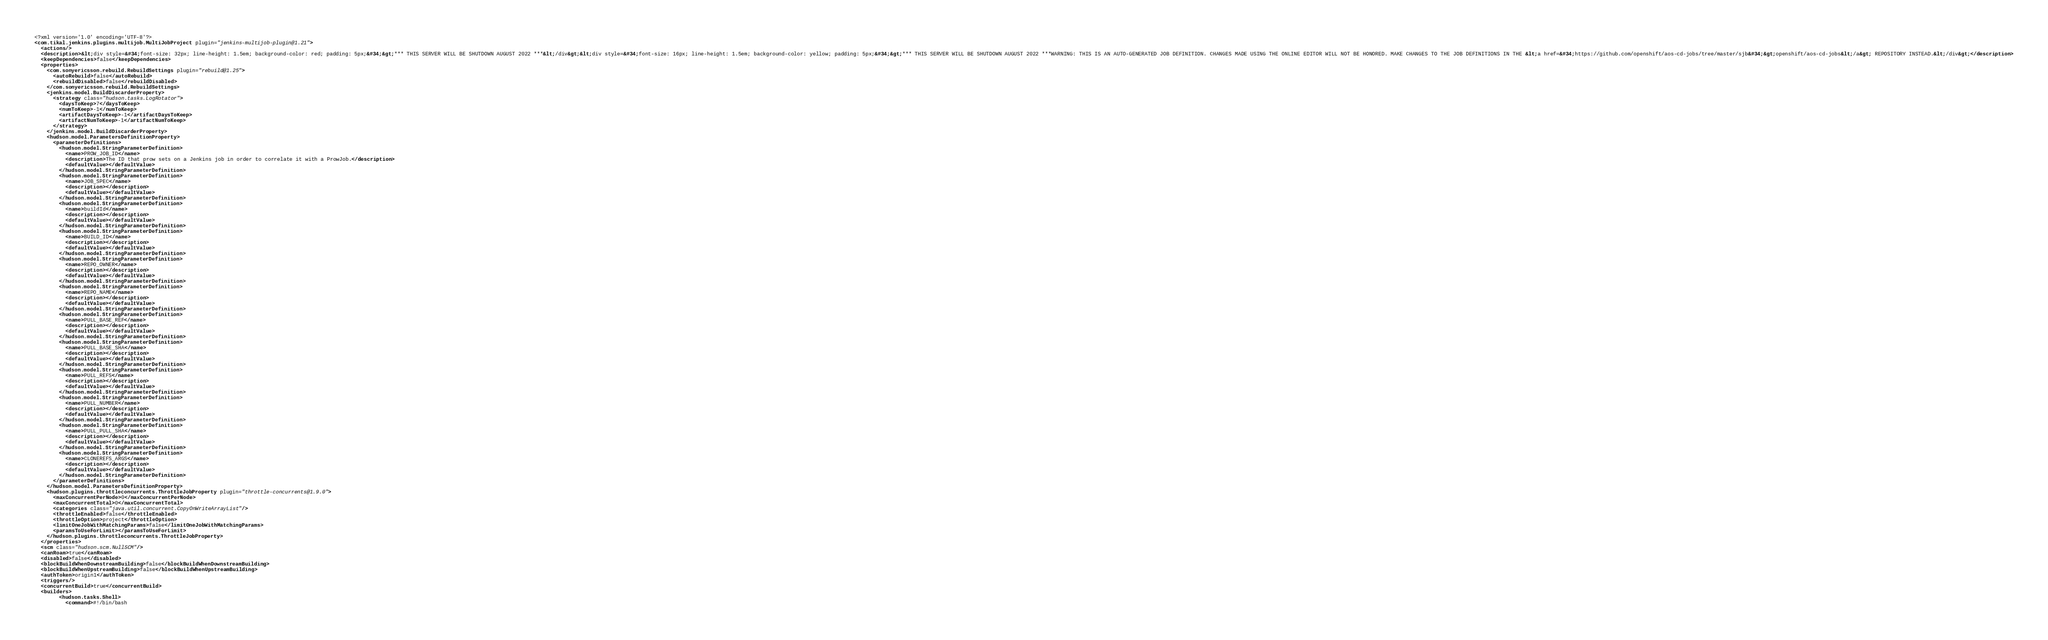<code> <loc_0><loc_0><loc_500><loc_500><_XML_><?xml version='1.0' encoding='UTF-8'?>
<com.tikal.jenkins.plugins.multijob.MultiJobProject plugin="jenkins-multijob-plugin@1.21">
  <actions/>
  <description>&lt;div style=&#34;font-size: 32px; line-height: 1.5em; background-color: red; padding: 5px;&#34;&gt;*** THIS SERVER WILL BE SHUTDOWN AUGUST 2022 ***&lt;/div&gt;&lt;div style=&#34;font-size: 16px; line-height: 1.5em; background-color: yellow; padding: 5px;&#34;&gt;*** THIS SERVER WILL BE SHUTDOWN AUGUST 2022 ***WARNING: THIS IS AN AUTO-GENERATED JOB DEFINITION. CHANGES MADE USING THE ONLINE EDITOR WILL NOT BE HONORED. MAKE CHANGES TO THE JOB DEFINITIONS IN THE &lt;a href=&#34;https://github.com/openshift/aos-cd-jobs/tree/master/sjb&#34;&gt;openshift/aos-cd-jobs&lt;/a&gt; REPOSITORY INSTEAD.&lt;/div&gt;</description>
  <keepDependencies>false</keepDependencies>
  <properties>
    <com.sonyericsson.rebuild.RebuildSettings plugin="rebuild@1.25">
      <autoRebuild>false</autoRebuild>
      <rebuildDisabled>false</rebuildDisabled>
    </com.sonyericsson.rebuild.RebuildSettings>
    <jenkins.model.BuildDiscarderProperty>
      <strategy class="hudson.tasks.LogRotator">
        <daysToKeep>7</daysToKeep>
        <numToKeep>-1</numToKeep>
        <artifactDaysToKeep>-1</artifactDaysToKeep>
        <artifactNumToKeep>-1</artifactNumToKeep>
      </strategy>
    </jenkins.model.BuildDiscarderProperty>
    <hudson.model.ParametersDefinitionProperty>
      <parameterDefinitions>
        <hudson.model.StringParameterDefinition>
          <name>PROW_JOB_ID</name>
          <description>The ID that prow sets on a Jenkins job in order to correlate it with a ProwJob.</description>
          <defaultValue></defaultValue>
        </hudson.model.StringParameterDefinition>
        <hudson.model.StringParameterDefinition>
          <name>JOB_SPEC</name>
          <description></description>
          <defaultValue></defaultValue>
        </hudson.model.StringParameterDefinition>
        <hudson.model.StringParameterDefinition>
          <name>buildId</name>
          <description></description>
          <defaultValue></defaultValue>
        </hudson.model.StringParameterDefinition>
        <hudson.model.StringParameterDefinition>
          <name>BUILD_ID</name>
          <description></description>
          <defaultValue></defaultValue>
        </hudson.model.StringParameterDefinition>
        <hudson.model.StringParameterDefinition>
          <name>REPO_OWNER</name>
          <description></description>
          <defaultValue></defaultValue>
        </hudson.model.StringParameterDefinition>
        <hudson.model.StringParameterDefinition>
          <name>REPO_NAME</name>
          <description></description>
          <defaultValue></defaultValue>
        </hudson.model.StringParameterDefinition>
        <hudson.model.StringParameterDefinition>
          <name>PULL_BASE_REF</name>
          <description></description>
          <defaultValue></defaultValue>
        </hudson.model.StringParameterDefinition>
        <hudson.model.StringParameterDefinition>
          <name>PULL_BASE_SHA</name>
          <description></description>
          <defaultValue></defaultValue>
        </hudson.model.StringParameterDefinition>
        <hudson.model.StringParameterDefinition>
          <name>PULL_REFS</name>
          <description></description>
          <defaultValue></defaultValue>
        </hudson.model.StringParameterDefinition>
        <hudson.model.StringParameterDefinition>
          <name>PULL_NUMBER</name>
          <description></description>
          <defaultValue></defaultValue>
        </hudson.model.StringParameterDefinition>
        <hudson.model.StringParameterDefinition>
          <name>PULL_PULL_SHA</name>
          <description></description>
          <defaultValue></defaultValue>
        </hudson.model.StringParameterDefinition>
        <hudson.model.StringParameterDefinition>
          <name>CLONEREFS_ARGS</name>
          <description></description>
          <defaultValue></defaultValue>
        </hudson.model.StringParameterDefinition>
      </parameterDefinitions>
    </hudson.model.ParametersDefinitionProperty>
    <hudson.plugins.throttleconcurrents.ThrottleJobProperty plugin="throttle-concurrents@1.9.0">
      <maxConcurrentPerNode>0</maxConcurrentPerNode>
      <maxConcurrentTotal>0</maxConcurrentTotal>
      <categories class="java.util.concurrent.CopyOnWriteArrayList"/>
      <throttleEnabled>false</throttleEnabled>
      <throttleOption>project</throttleOption>
      <limitOneJobWithMatchingParams>false</limitOneJobWithMatchingParams>
      <paramsToUseForLimit></paramsToUseForLimit>
    </hudson.plugins.throttleconcurrents.ThrottleJobProperty>
  </properties>
  <scm class="hudson.scm.NullSCM"/>
  <canRoam>true</canRoam>
  <disabled>false</disabled>
  <blockBuildWhenDownstreamBuilding>false</blockBuildWhenDownstreamBuilding>
  <blockBuildWhenUpstreamBuilding>false</blockBuildWhenUpstreamBuilding>
  <authToken>origin1</authToken>
  <triggers/>
  <concurrentBuild>true</concurrentBuild>
  <builders>
        <hudson.tasks.Shell>
          <command>#!/bin/bash</code> 